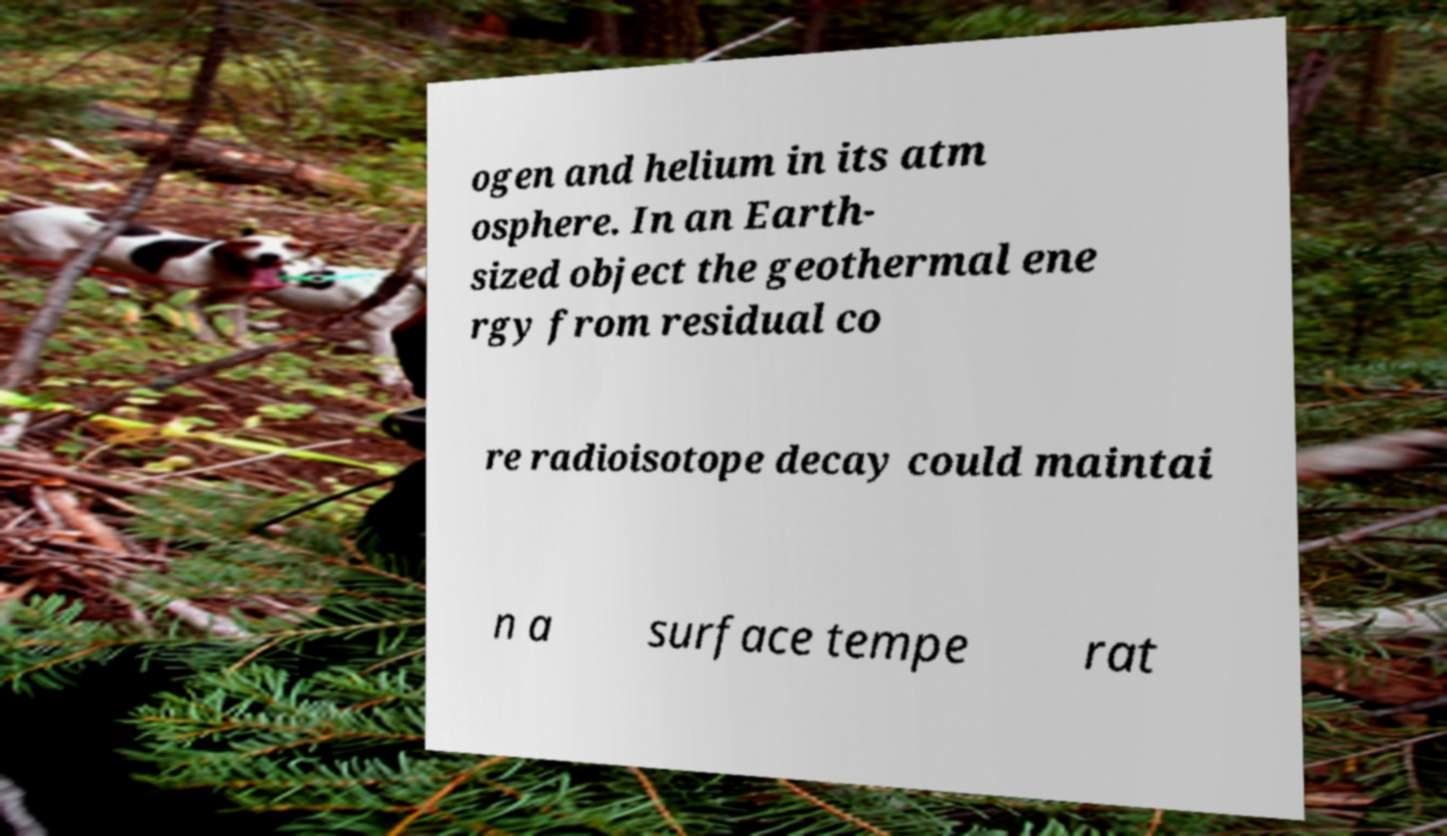Could you assist in decoding the text presented in this image and type it out clearly? ogen and helium in its atm osphere. In an Earth- sized object the geothermal ene rgy from residual co re radioisotope decay could maintai n a surface tempe rat 